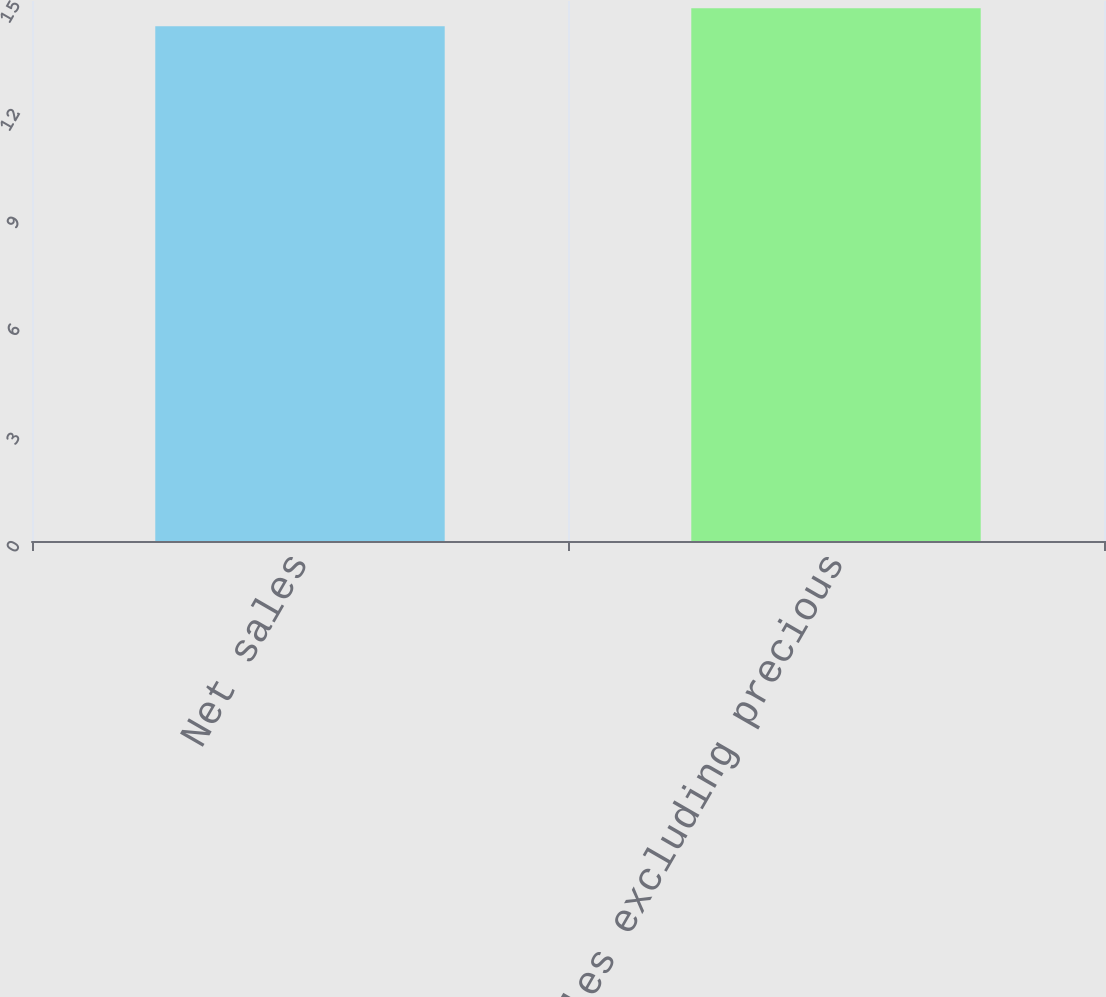Convert chart. <chart><loc_0><loc_0><loc_500><loc_500><bar_chart><fcel>Net sales<fcel>Net sales excluding precious<nl><fcel>14.3<fcel>14.8<nl></chart> 